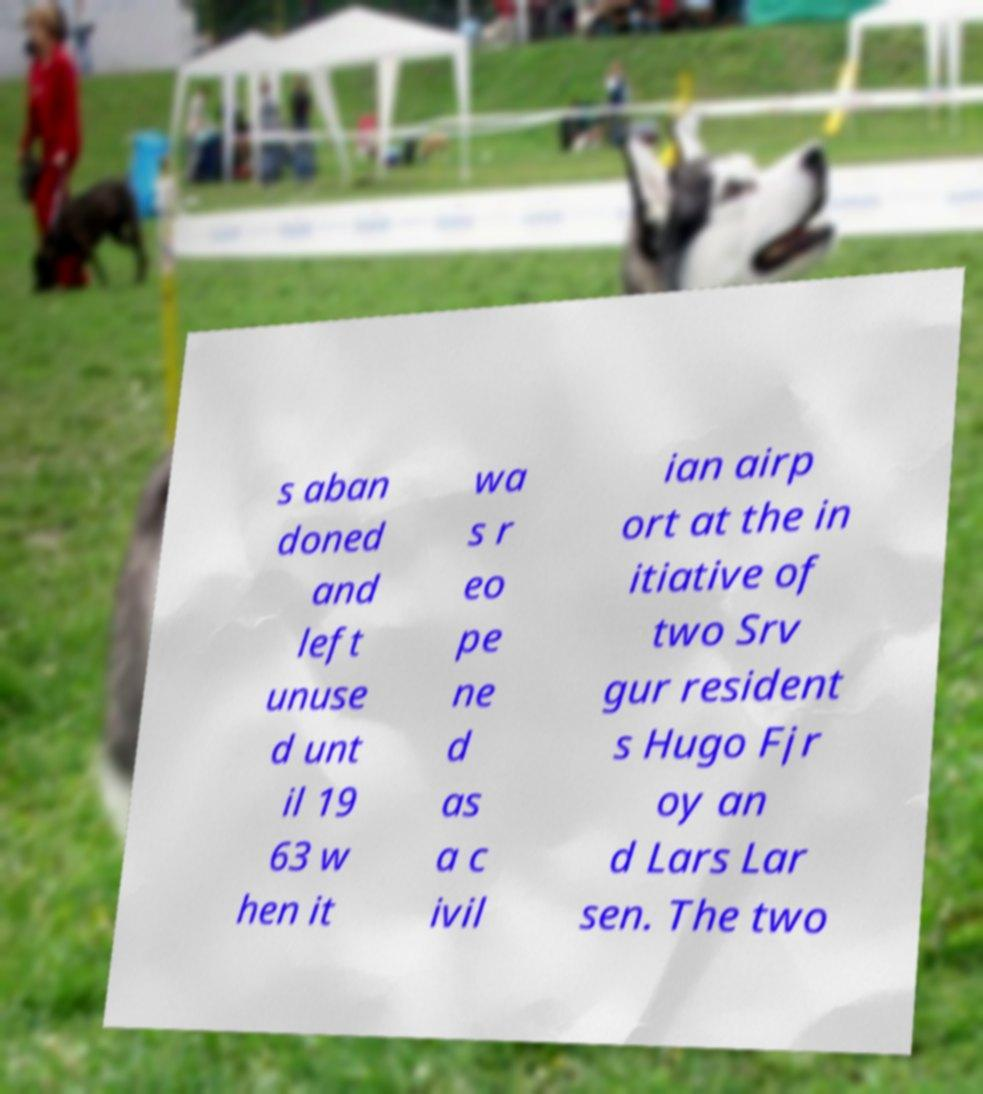Could you assist in decoding the text presented in this image and type it out clearly? s aban doned and left unuse d unt il 19 63 w hen it wa s r eo pe ne d as a c ivil ian airp ort at the in itiative of two Srv gur resident s Hugo Fjr oy an d Lars Lar sen. The two 